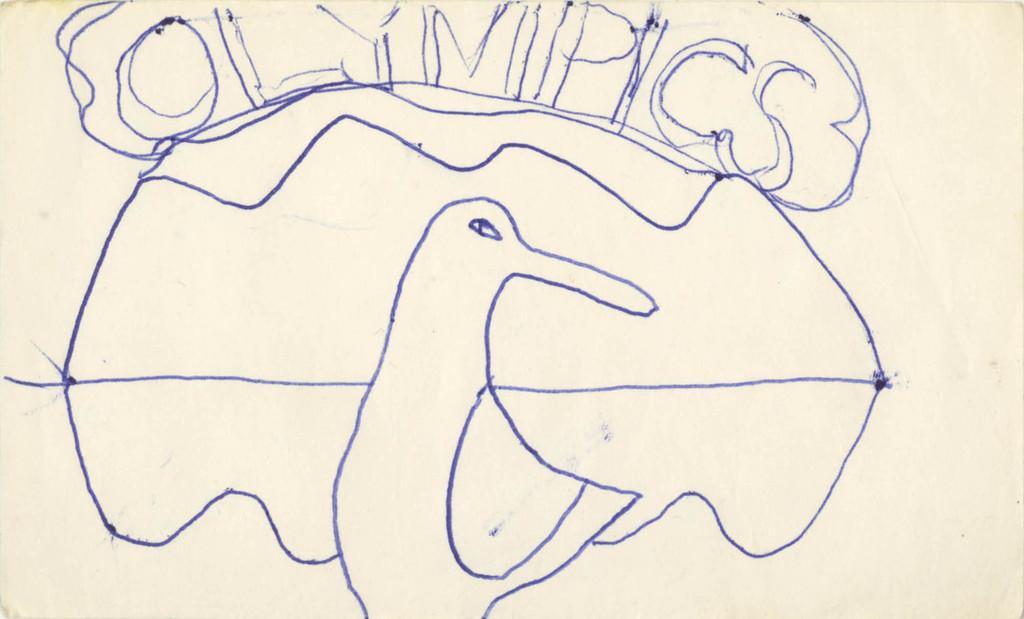Please provide a concise description of this image. This is a paper. In this image we can see sketch of a bird and some text are there. 